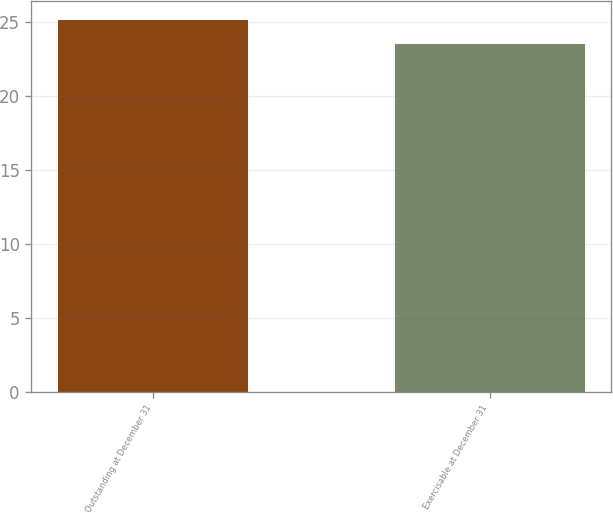Convert chart. <chart><loc_0><loc_0><loc_500><loc_500><bar_chart><fcel>Outstanding at December 31<fcel>Exercisable at December 31<nl><fcel>25.17<fcel>23.51<nl></chart> 